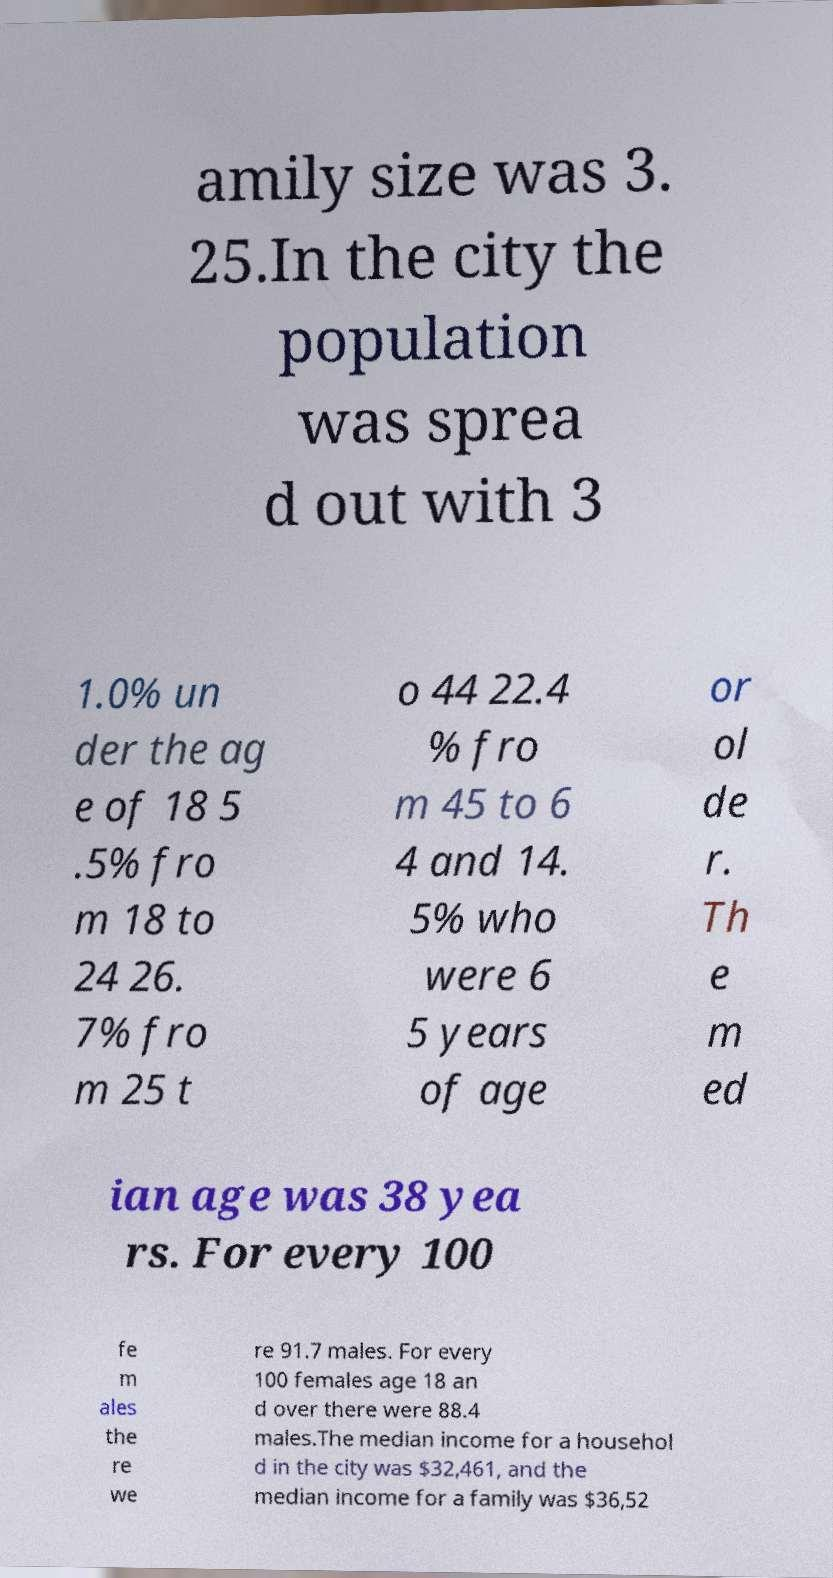Can you accurately transcribe the text from the provided image for me? amily size was 3. 25.In the city the population was sprea d out with 3 1.0% un der the ag e of 18 5 .5% fro m 18 to 24 26. 7% fro m 25 t o 44 22.4 % fro m 45 to 6 4 and 14. 5% who were 6 5 years of age or ol de r. Th e m ed ian age was 38 yea rs. For every 100 fe m ales the re we re 91.7 males. For every 100 females age 18 an d over there were 88.4 males.The median income for a househol d in the city was $32,461, and the median income for a family was $36,52 